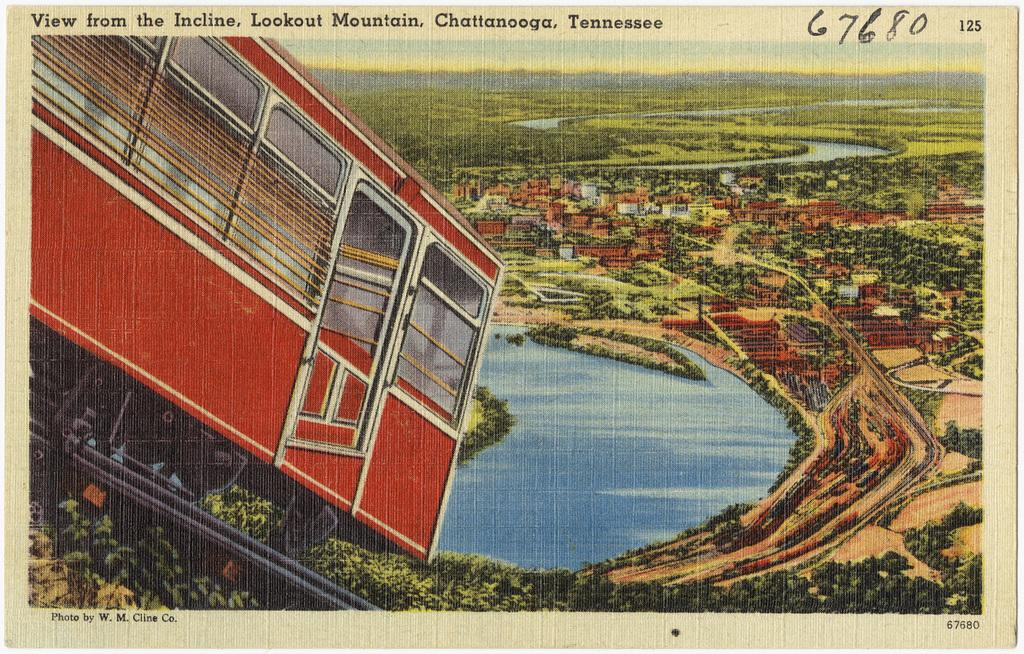<image>
Give a short and clear explanation of the subsequent image. A postcard with a view of Lookout Mountain in Tennessee. 